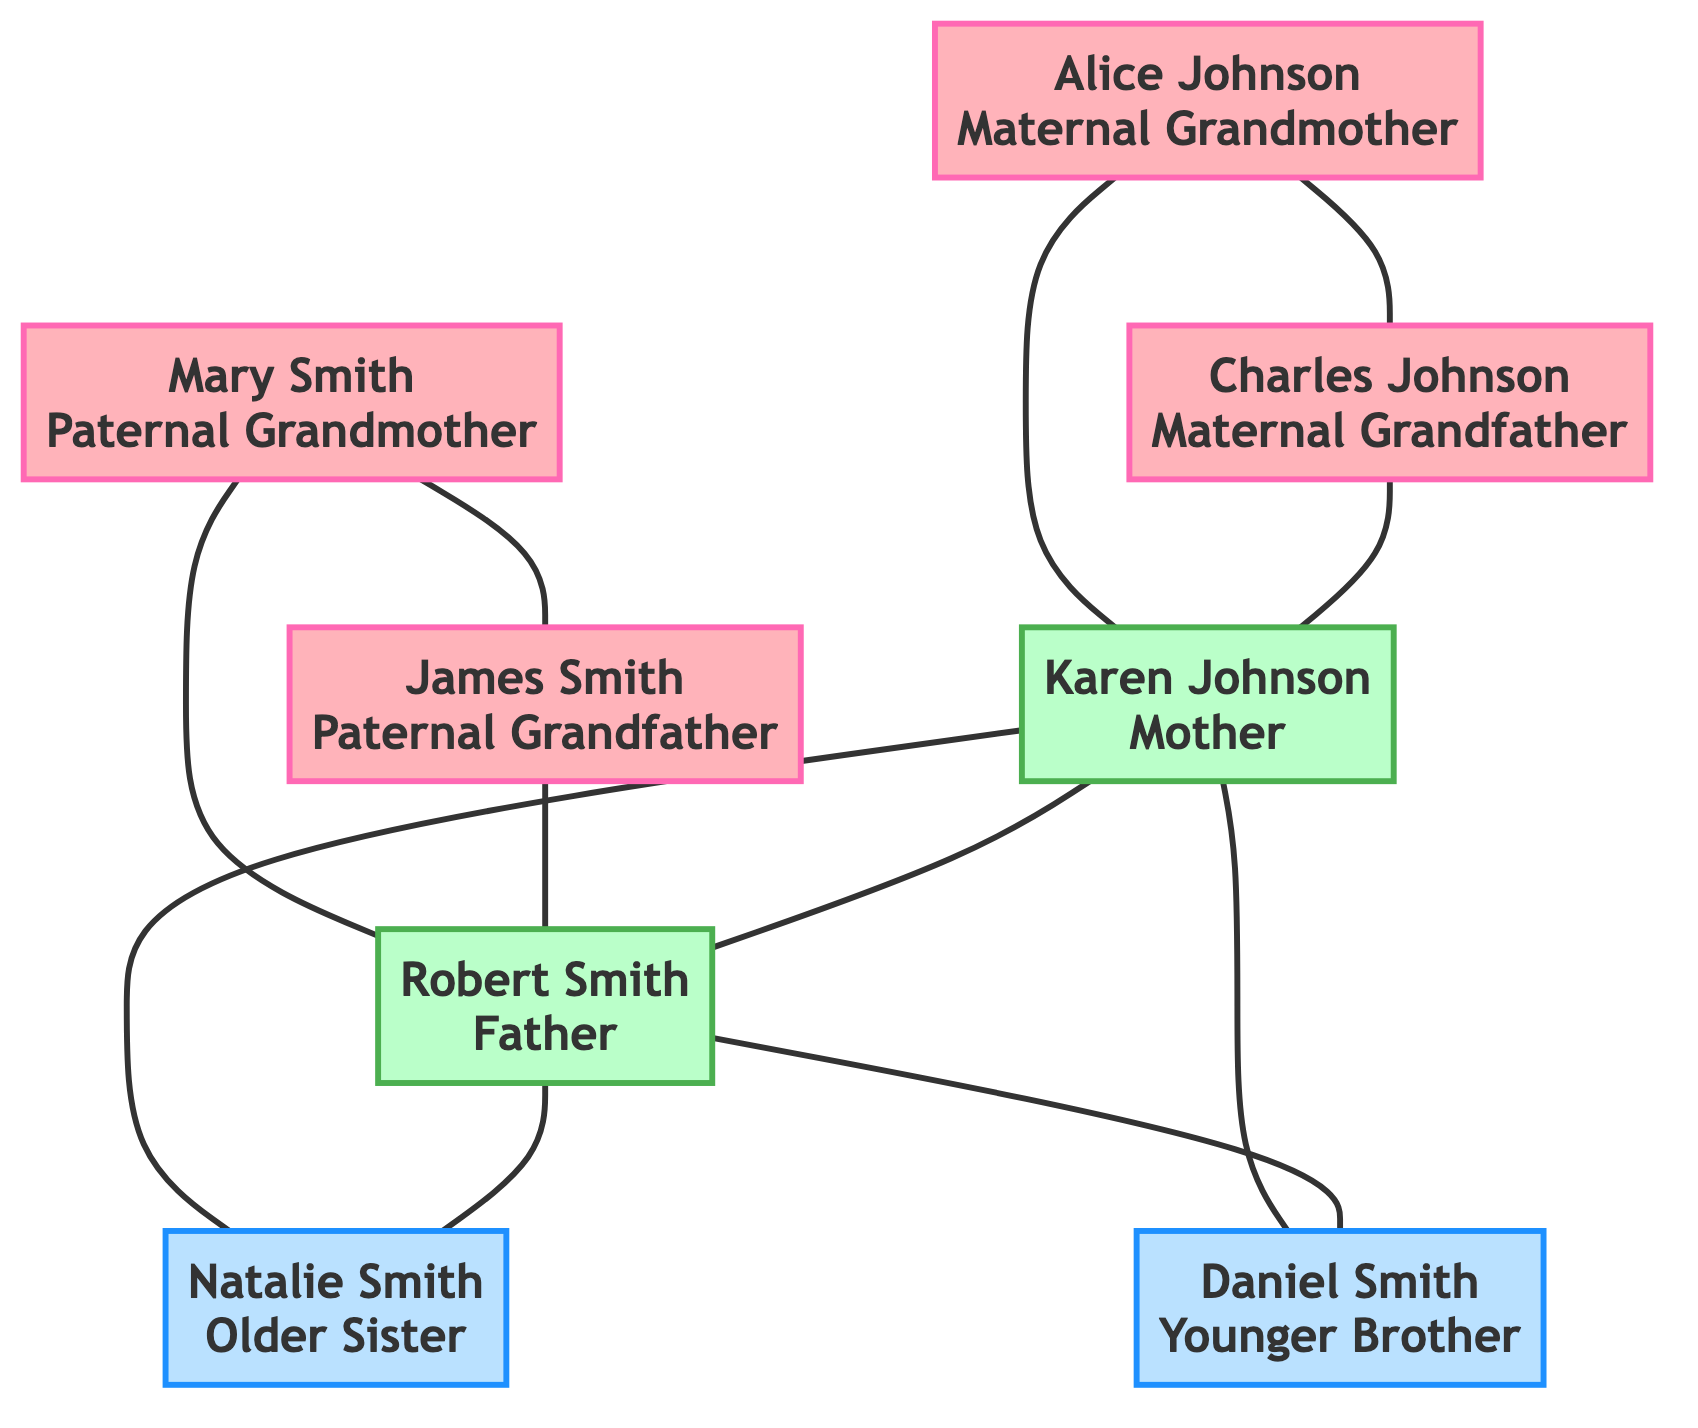What is the role of Karen Johnson in the family tree? Karen Johnson is identified as the "Mother" in the family tree. Her role is central to emotional support and care, which is highlighted in the description under her name.
Answer: Mother Who is the paternal grandmother? The paternal grandmother is named Mary Smith, as indicated in the family tree's definitions for family roles.
Answer: Mary Smith How many children do Karen Johnson and Robert Smith have? Karen Johnson and Robert Smith, identified as the parents in the diagram, have two children listed: Natalie Smith and Daniel Smith. Thus, the total number is two.
Answer: Two What impact does Alice Johnson have on the family? Alice Johnson is described as having an impact as a guardian and emotional supporter. Her influence aids in crisis management and emotional stability within the family.
Answer: Guardian and emotional supporter Which sibling is the older sister? The older sister in the family tree is identified as Natalie Smith. This is made clear in the sibling connections outlined in the diagram.
Answer: Natalie Smith What is the connection between Alice Johnson and Karen Johnson? Alice Johnson is Karen Johnson's mother, as indicated by the maternal lineage in the family tree, highlighting their direct familial relationship.
Answer: Mother How does Robert Smith’s role affect his children? Robert Smith, as the father, is characterized as a key provider and protective figure. His approach to parenting influences his children's social behavior and academic success, indicating a direct impact on their development.
Answer: Provider and protective figure Who provides nurturing in the family? Mary Smith, the paternal grandmother, is noted for providing nurturing and caring, particularly during the absence of the mother. This role significantly shapes perspectives on gender roles and caregiving.
Answer: Mary Smith What is the relationship between Natalie Smith and Daniel Smith? Natalie Smith is the older sister, while Daniel Smith is the younger brother, establishing a sibling relationship in the family tree.
Answer: Siblings 